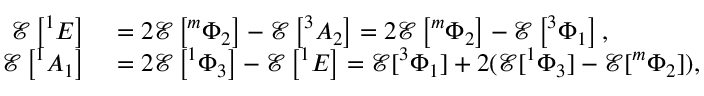Convert formula to latex. <formula><loc_0><loc_0><loc_500><loc_500>\begin{array} { r l } { \mathcal { E } \left ^ { 1 } E \right ] } & = 2 \mathcal { E } \left ^ { m } \Phi _ { 2 } \right ] - \mathcal { E } \left ^ { 3 } A _ { 2 } \right ] = 2 \mathcal { E } \left ^ { m } \Phi _ { 2 } \right ] - \mathcal { E } \left ^ { 3 } \Phi _ { 1 } \right ] , } \\ { \mathcal { E } \left ^ { 1 } A _ { 1 } \right ] } & = 2 \mathcal { E } \left ^ { 1 } \Phi _ { 3 } \right ] - \mathcal { E } \left ^ { 1 } E \right ] = \mathcal { E } ^ { 3 } \Phi _ { 1 } ] + 2 ( \mathcal { E } ^ { 1 } \Phi _ { 3 } ] - \mathcal { E } ^ { m } \Phi _ { 2 } ] ) , } \end{array}</formula> 